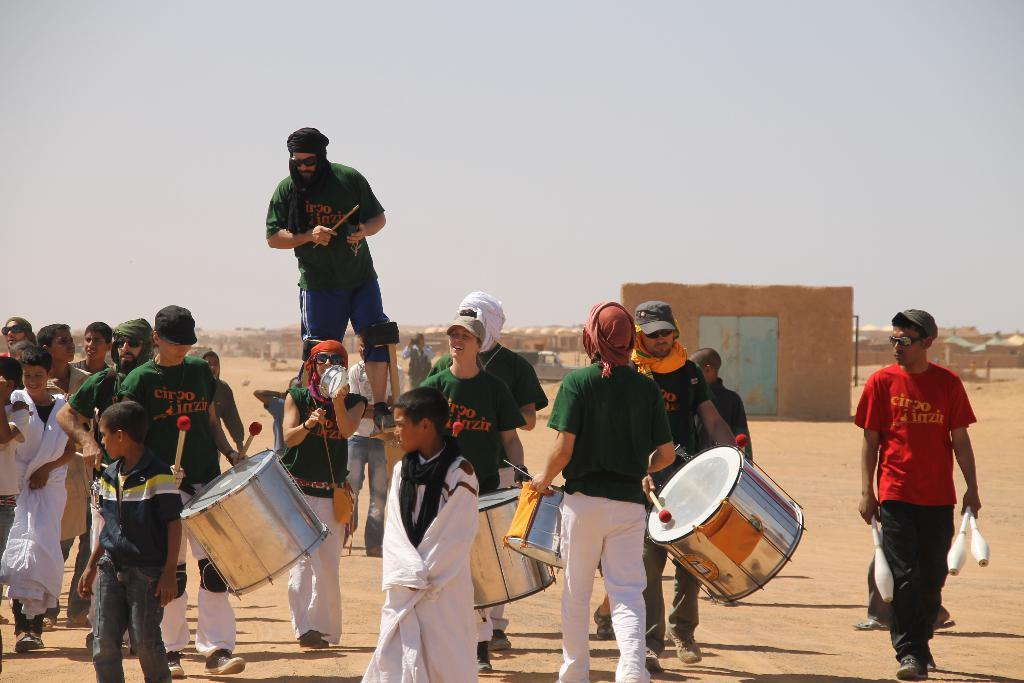What are the persons in the image doing? The persons in the image are playing drums. What can be seen in the background of the image? There is a sky visible in the background of the image. Can you describe any architectural features in the image? Yes, there is a door in the image. What type of plants can be seen growing in the image? There are no plants visible in the image. What grade is the person playing the drums in? There is no information about the person's grade in the image. 